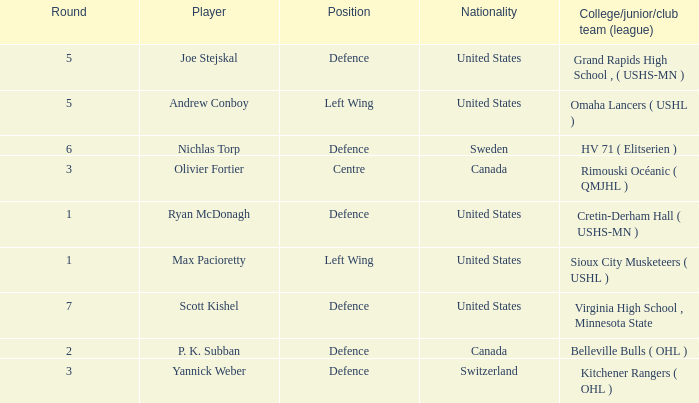I'm looking to parse the entire table for insights. Could you assist me with that? {'header': ['Round', 'Player', 'Position', 'Nationality', 'College/junior/club team (league)'], 'rows': [['5', 'Joe Stejskal', 'Defence', 'United States', 'Grand Rapids High School , ( USHS-MN )'], ['5', 'Andrew Conboy', 'Left Wing', 'United States', 'Omaha Lancers ( USHL )'], ['6', 'Nichlas Torp', 'Defence', 'Sweden', 'HV 71 ( Elitserien )'], ['3', 'Olivier Fortier', 'Centre', 'Canada', 'Rimouski Océanic ( QMJHL )'], ['1', 'Ryan McDonagh', 'Defence', 'United States', 'Cretin-Derham Hall ( USHS-MN )'], ['1', 'Max Pacioretty', 'Left Wing', 'United States', 'Sioux City Musketeers ( USHL )'], ['7', 'Scott Kishel', 'Defence', 'United States', 'Virginia High School , Minnesota State'], ['2', 'P. K. Subban', 'Defence', 'Canada', 'Belleville Bulls ( OHL )'], ['3', 'Yannick Weber', 'Defence', 'Switzerland', 'Kitchener Rangers ( OHL )']]} Which player from the United States plays defence and was chosen before round 5? Ryan McDonagh. 